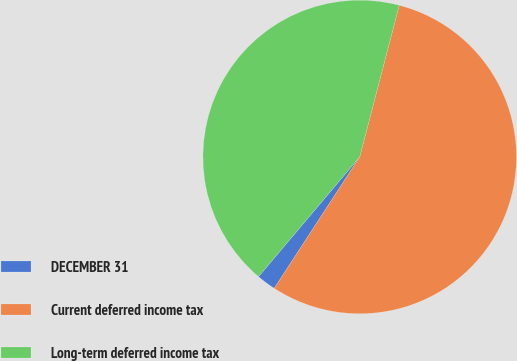Convert chart. <chart><loc_0><loc_0><loc_500><loc_500><pie_chart><fcel>DECEMBER 31<fcel>Current deferred income tax<fcel>Long-term deferred income tax<nl><fcel>1.99%<fcel>55.12%<fcel>42.89%<nl></chart> 